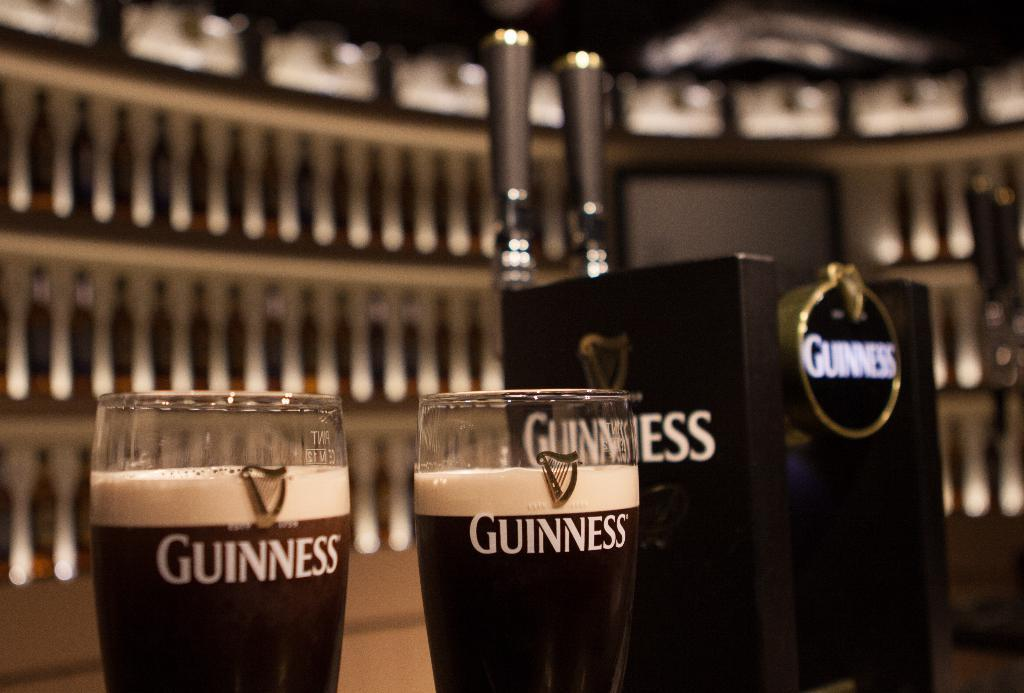Provide a one-sentence caption for the provided image. Two glasses of Guinness sit next to a set of Guinness taps at a bar. 